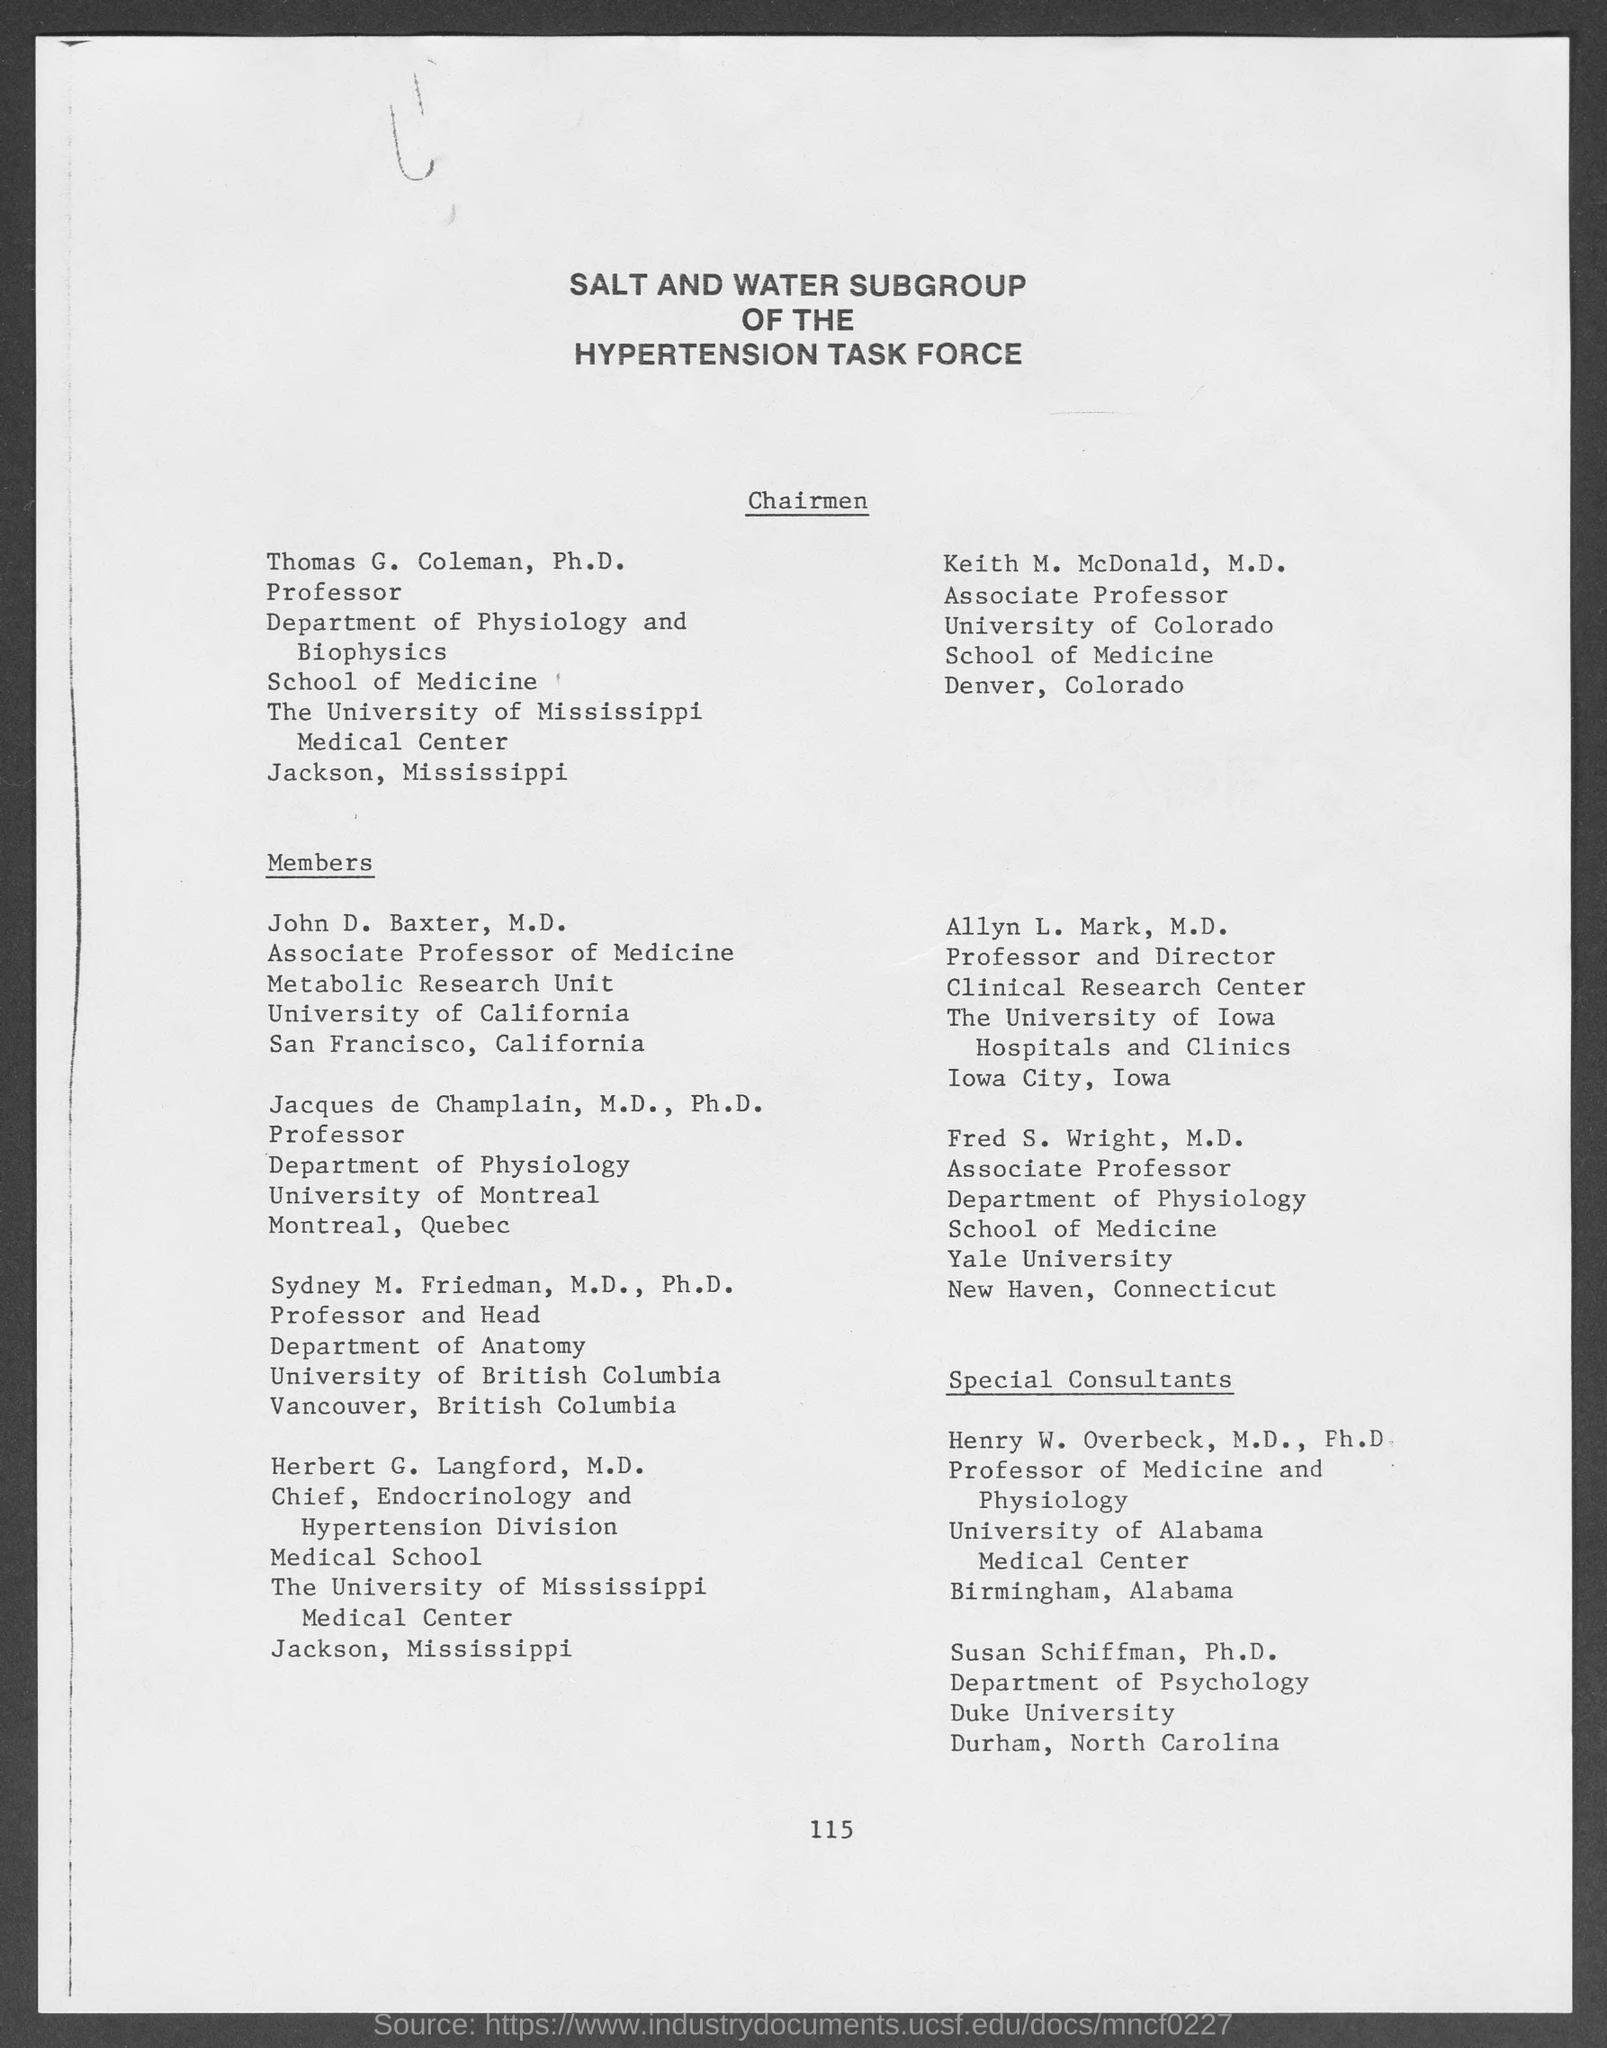What is the position of thomas g. coleman, ph.d ?
Give a very brief answer. Professor. What is the position of keith m. mcdonald, m.d. ?
Offer a terse response. Associate professor. What is the position of john. d. baxter, m.d. ?
Your answer should be compact. Associate Professor of Medicine. What are the positions of allya l. mark, m.d. ?
Your answer should be compact. Professor and Director. What is the position of jacques de champlain, m.d., ph.d. ?
Make the answer very short. Professor. To which depart does sydney m. friedman, m.d., ph.d. belong ?
Your response must be concise. Department of Anatomy. What is the position of fred s. wright, m.d. ?
Offer a terse response. Associate Professor. What is the position of henry w. overbeck, m.d., ph.d.?
Offer a terse response. Professor of Medicine and Physiology. To which department does susan schiffman, ph.d. belong ?
Offer a terse response. Department of Psychology. 